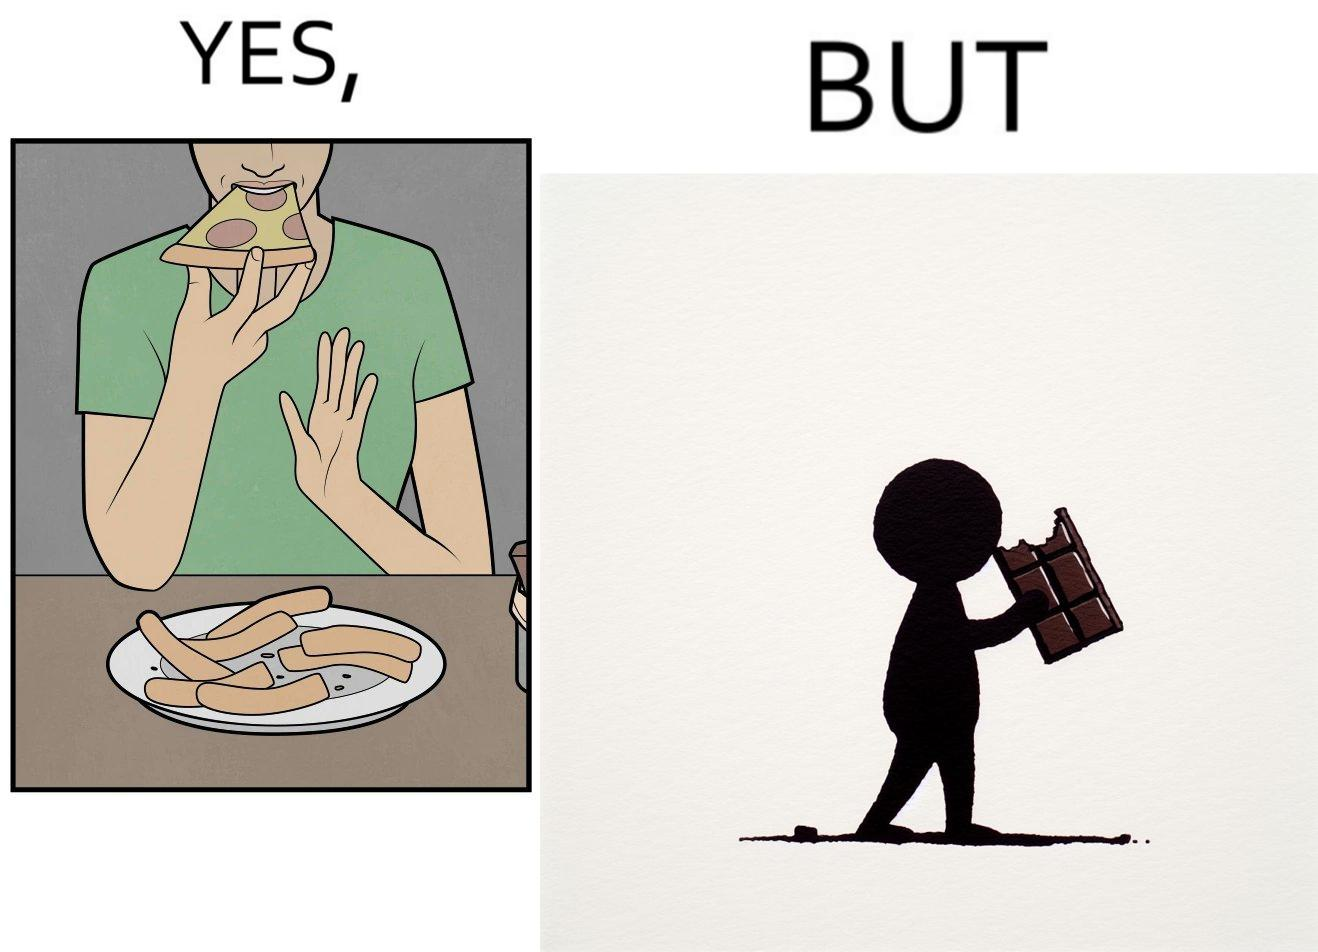Is this a satirical image? Yes, this image is satirical. 